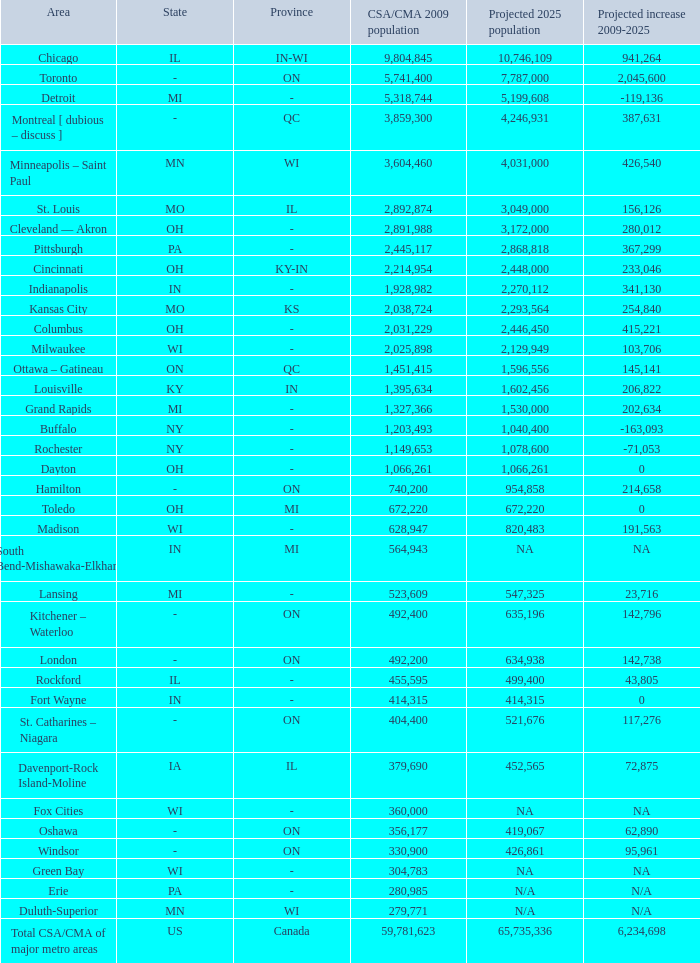What's the CSA/CMA Population in IA-IL? 379690.0. 